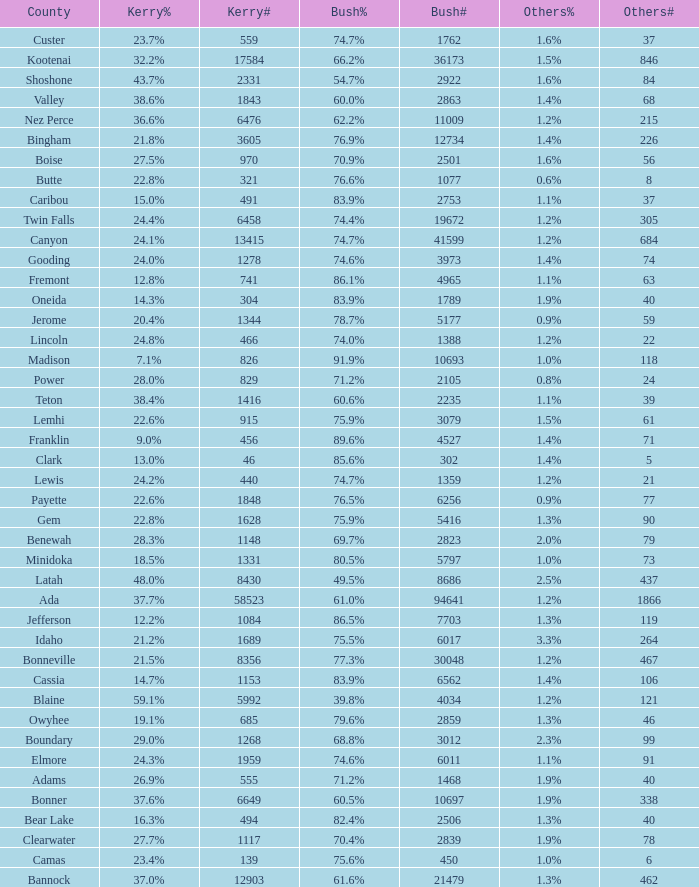What percentage of the votes were for others in the county where 462 people voted that way? 1.3%. 